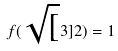Convert formula to latex. <formula><loc_0><loc_0><loc_500><loc_500>f ( \sqrt { [ } 3 ] { 2 } ) = 1</formula> 